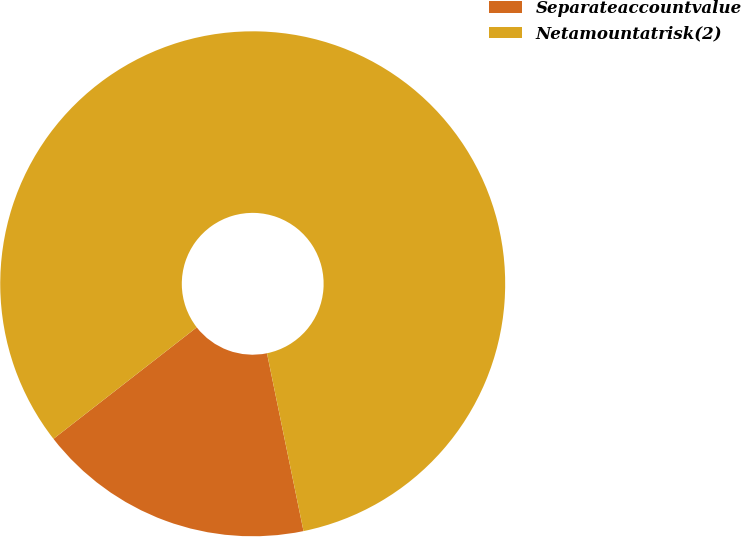<chart> <loc_0><loc_0><loc_500><loc_500><pie_chart><fcel>Separateaccountvalue<fcel>Netamountatrisk(2)<nl><fcel>17.7%<fcel>82.3%<nl></chart> 